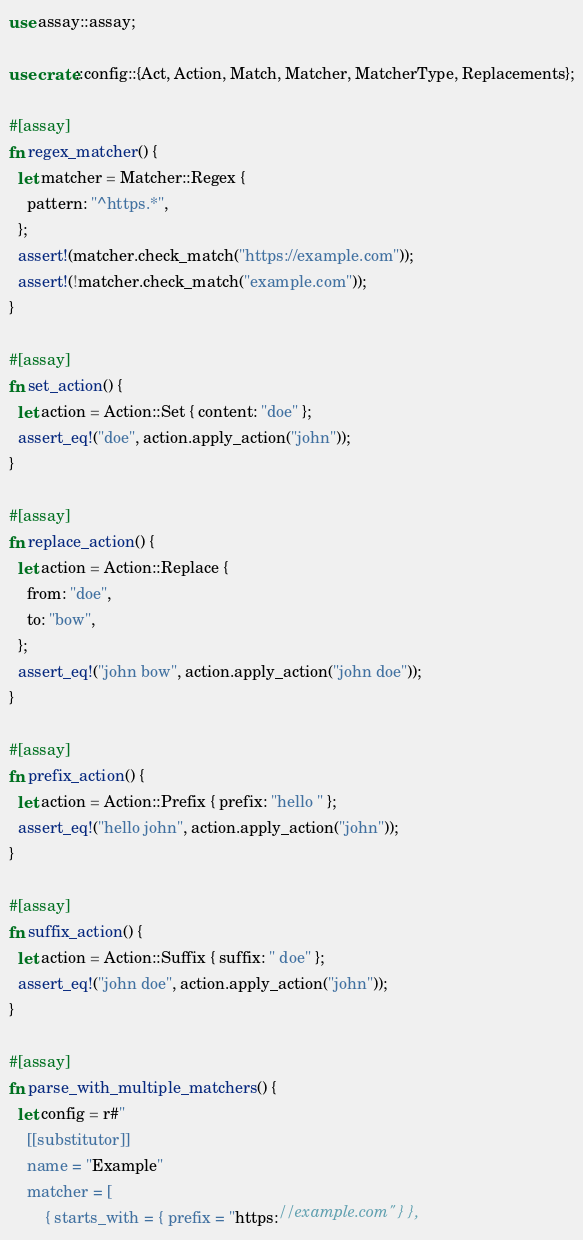<code> <loc_0><loc_0><loc_500><loc_500><_Rust_>use assay::assay;

use crate::config::{Act, Action, Match, Matcher, MatcherType, Replacements};

#[assay]
fn regex_matcher() {
  let matcher = Matcher::Regex {
    pattern: "^https.*",
  };
  assert!(matcher.check_match("https://example.com"));
  assert!(!matcher.check_match("example.com"));
}

#[assay]
fn set_action() {
  let action = Action::Set { content: "doe" };
  assert_eq!("doe", action.apply_action("john"));
}

#[assay]
fn replace_action() {
  let action = Action::Replace {
    from: "doe",
    to: "bow",
  };
  assert_eq!("john bow", action.apply_action("john doe"));
}

#[assay]
fn prefix_action() {
  let action = Action::Prefix { prefix: "hello " };
  assert_eq!("hello john", action.apply_action("john"));
}

#[assay]
fn suffix_action() {
  let action = Action::Suffix { suffix: " doe" };
  assert_eq!("john doe", action.apply_action("john"));
}

#[assay]
fn parse_with_multiple_matchers() {
  let config = r#"
    [[substitutor]]
    name = "Example"
    matcher = [
        { starts_with = { prefix = "https://example.com" } },</code> 